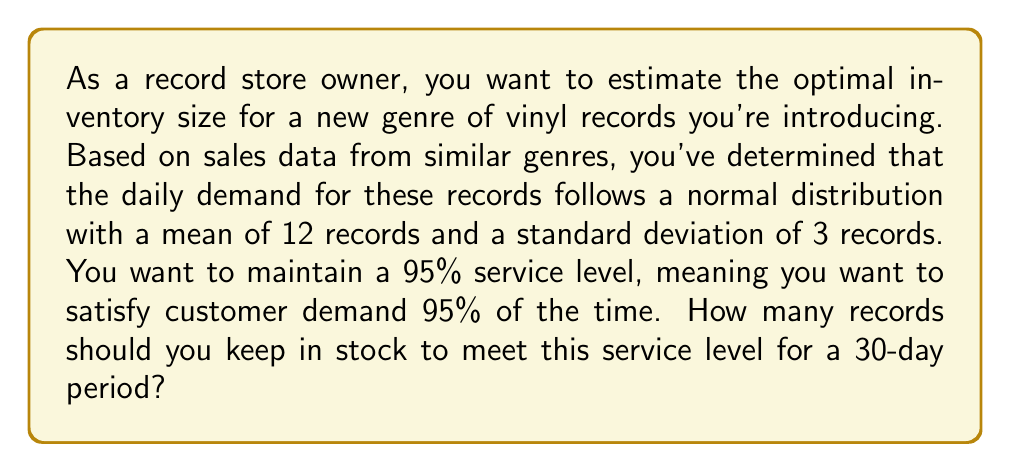Solve this math problem. To solve this problem, we'll use the concept of safety stock and the properties of the normal distribution. Here's a step-by-step approach:

1. Calculate the mean demand for the 30-day period:
   $\mu_{30} = 30 \times 12 = 360$ records

2. Calculate the standard deviation for the 30-day period:
   $\sigma_{30} = \sqrt{30} \times 3 = 3\sqrt{30} \approx 16.43$ records

3. Determine the z-score for a 95% service level:
   For a 95% service level, we need the z-score that corresponds to the 95th percentile of the standard normal distribution. This z-score is approximately 1.645.

4. Calculate the safety stock:
   Safety Stock $= z \times \sigma_{30} = 1.645 \times 16.43 \approx 27.03$ records

5. Calculate the optimal inventory size:
   Optimal Inventory $= \mu_{30} + \text{Safety Stock}$
   $= 360 + 27.03 \approx 387.03$ records

Since we can't stock fractional records, we round up to the nearest whole number.

The formula for the optimal inventory size can be expressed as:

$$ \text{Optimal Inventory} = \mu_{30} + z \times \sigma_{30} $$

Where:
$\mu_{30}$ is the mean demand for 30 days
$z$ is the z-score for the desired service level
$\sigma_{30}$ is the standard deviation of demand for 30 days
Answer: The optimal inventory size is 388 records. 